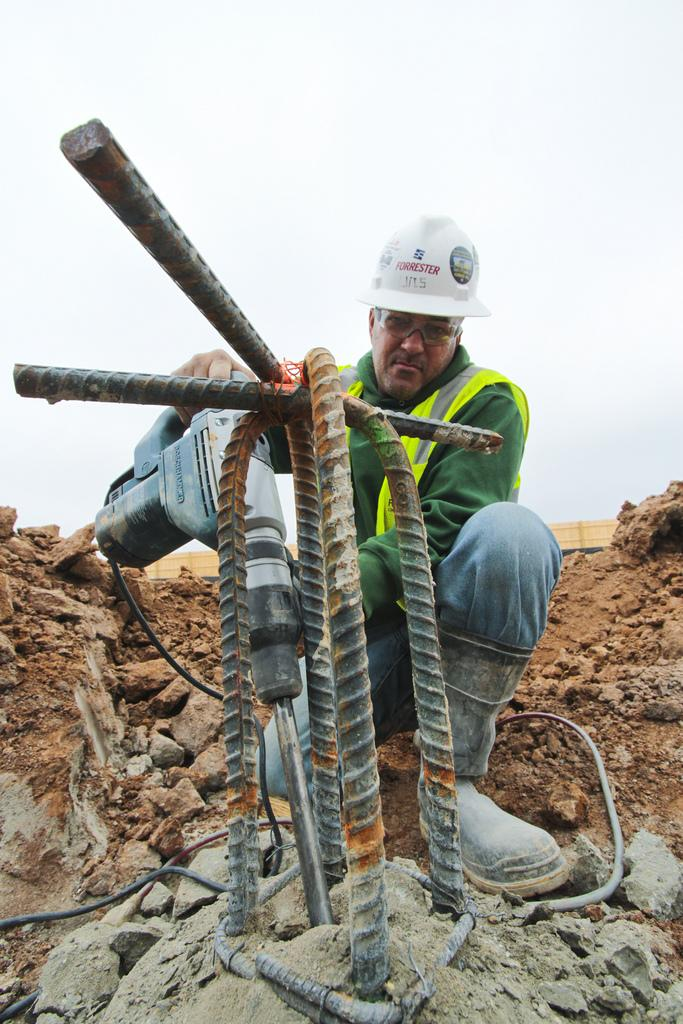What is located in the middle of the image? There are iron bars in the middle of the image. What is the man in the image doing? The man is drilling with a drilling machine. What protective gear is the man wearing? The man is wearing a helmet. What can be seen at the top of the image? The sky is visible at the top of the image. What type of vegetable is being used as a drill bit in the image? There is no vegetable being used as a drill bit in the image; the man is using a drilling machine. What sound does the alarm make in the image? There is no alarm present in the image. 